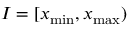<formula> <loc_0><loc_0><loc_500><loc_500>I = [ x _ { \min } , x _ { \max } )</formula> 